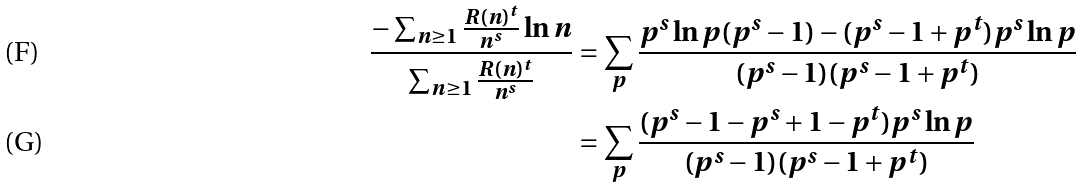Convert formula to latex. <formula><loc_0><loc_0><loc_500><loc_500>\frac { - \sum _ { n \geq 1 } \frac { R ( n ) ^ { t } } { n ^ { s } } \ln n } { \sum _ { n \geq 1 } \frac { R ( n ) ^ { t } } { n ^ { s } } } & = \sum _ { p } \frac { p ^ { s } \ln p ( p ^ { s } - 1 ) - ( p ^ { s } - 1 + p ^ { t } ) p ^ { s } \ln p } { ( p ^ { s } - 1 ) ( p ^ { s } - 1 + p ^ { t } ) } \\ & = \sum _ { p } \frac { ( p ^ { s } - 1 - p ^ { s } + 1 - p ^ { t } ) p ^ { s } \ln p } { ( p ^ { s } - 1 ) ( p ^ { s } - 1 + p ^ { t } ) }</formula> 